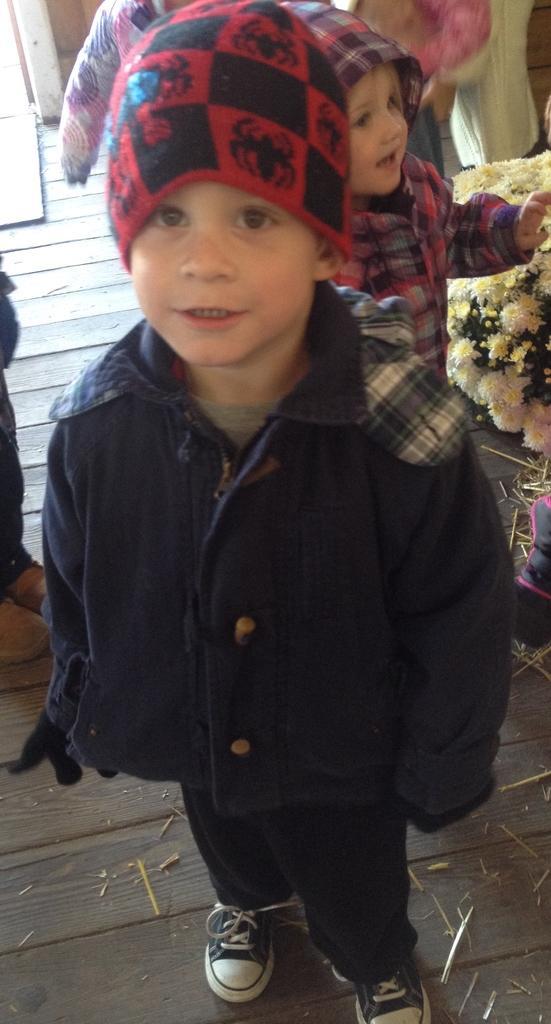Can you describe this image briefly? In this picture we can observe a boy standing on the wooden surface. He is wearing a jacket and a red color cap on his head. Behind him there is a girl standing. We can observe some flowers on the right side. 